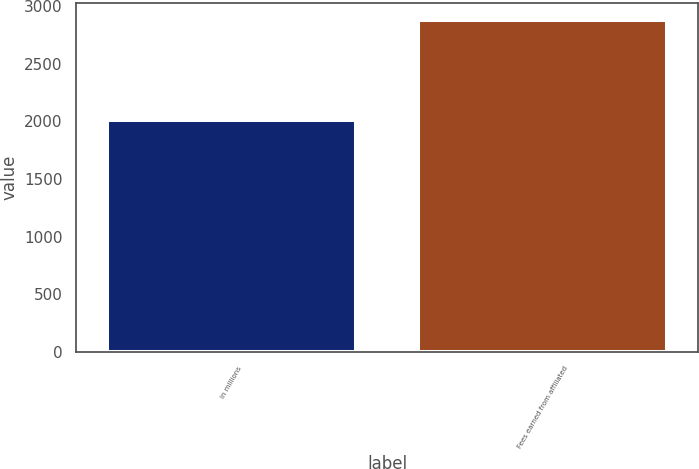<chart> <loc_0><loc_0><loc_500><loc_500><bar_chart><fcel>in millions<fcel>Fees earned from affiliated<nl><fcel>2010<fcel>2882<nl></chart> 